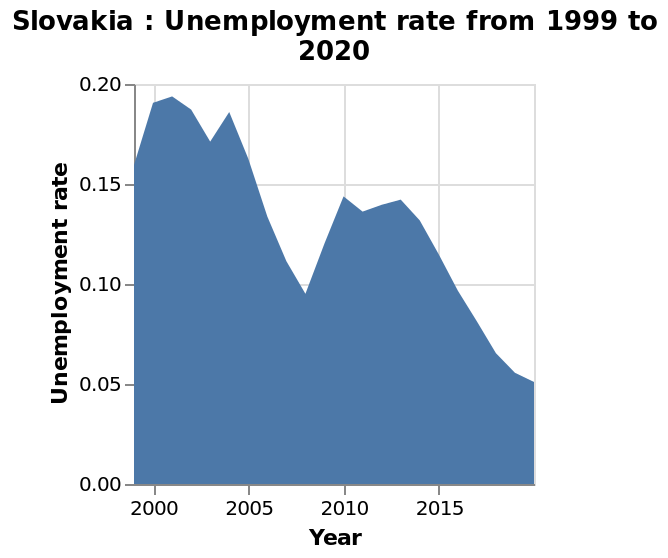<image>
What does the x-axis measure on the line graph?  The x-axis measures the year. What does the y-axis measure in the graph?  The y-axis measures the unemployment rate. What is the time range represented in the graph?  The graph represents the unemployment rate from 1999 to 2020. Was there a steady decrease in unemployment between 2004 and 2008?  Yes, between 2004 and 2008, there was a steady decrease in unemployment in Slovakia. Does the graph represent the unemployment rate from 2020 to 1999? No. The graph represents the unemployment rate from 1999 to 2020. Was there a significant increase in unemployment in Slovakia between 2004 and 2008? No. Yes, between 2004 and 2008, there was a steady decrease in unemployment in Slovakia. 